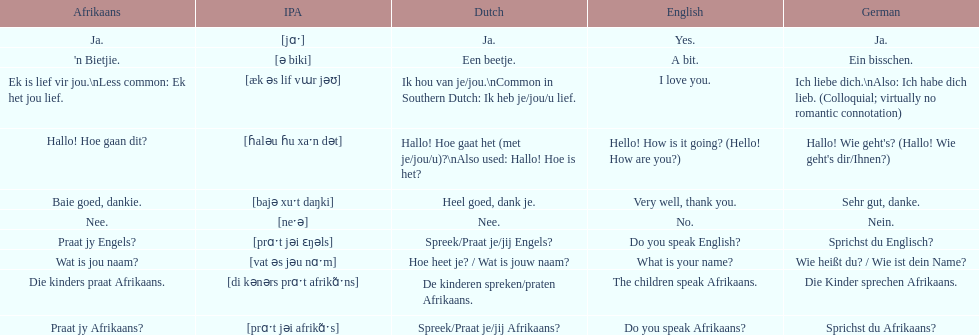Translate the following into english: 'n bietjie. A bit. 